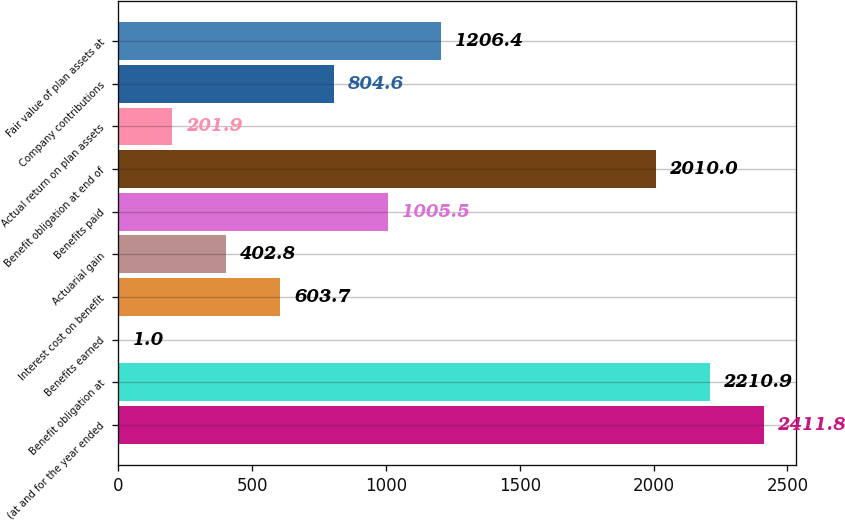<chart> <loc_0><loc_0><loc_500><loc_500><bar_chart><fcel>(at and for the year ended<fcel>Benefit obligation at<fcel>Benefits earned<fcel>Interest cost on benefit<fcel>Actuarial gain<fcel>Benefits paid<fcel>Benefit obligation at end of<fcel>Actual return on plan assets<fcel>Company contributions<fcel>Fair value of plan assets at<nl><fcel>2411.8<fcel>2210.9<fcel>1<fcel>603.7<fcel>402.8<fcel>1005.5<fcel>2010<fcel>201.9<fcel>804.6<fcel>1206.4<nl></chart> 